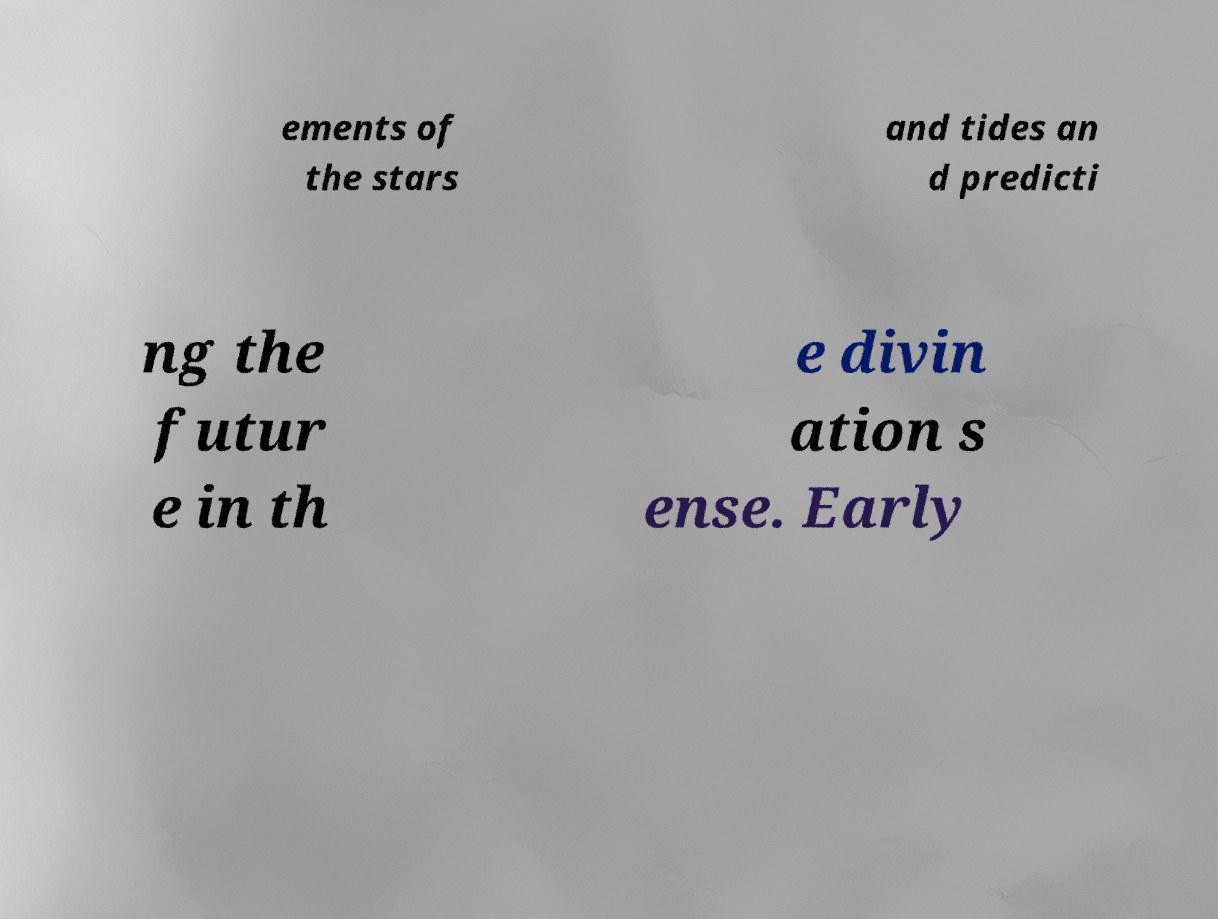What messages or text are displayed in this image? I need them in a readable, typed format. ements of the stars and tides an d predicti ng the futur e in th e divin ation s ense. Early 